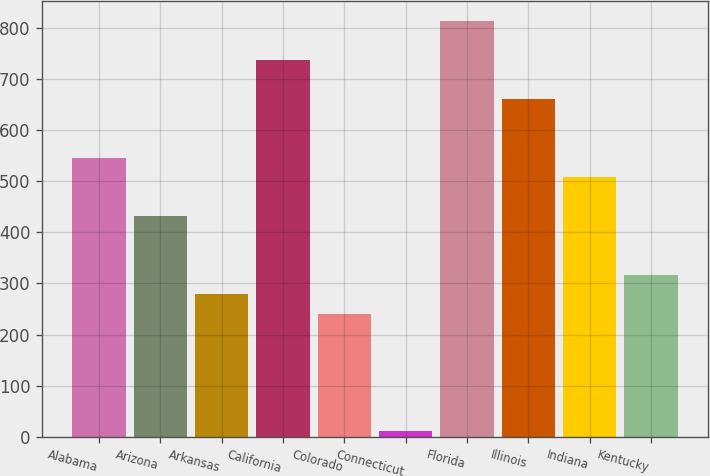<chart> <loc_0><loc_0><loc_500><loc_500><bar_chart><fcel>Alabama<fcel>Arizona<fcel>Arkansas<fcel>California<fcel>Colorado<fcel>Connecticut<fcel>Florida<fcel>Illinois<fcel>Indiana<fcel>Kentucky<nl><fcel>545.4<fcel>431.1<fcel>278.7<fcel>735.9<fcel>240.6<fcel>12<fcel>812.1<fcel>659.7<fcel>507.3<fcel>316.8<nl></chart> 